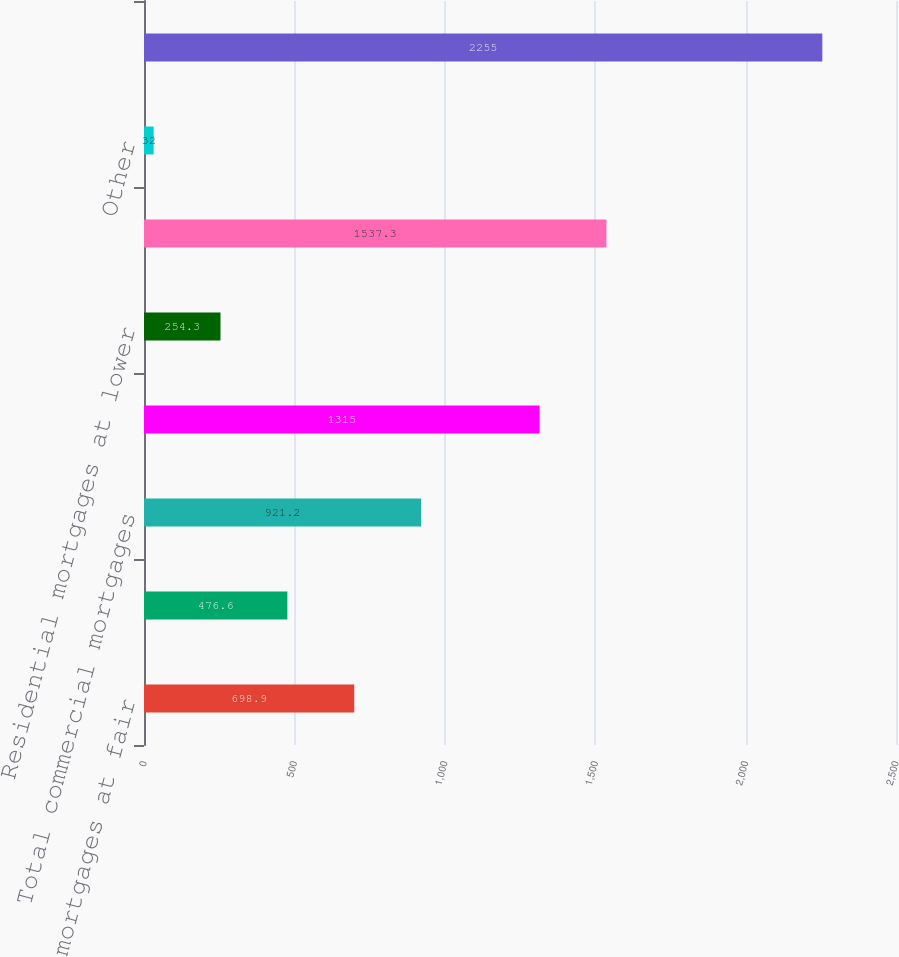<chart> <loc_0><loc_0><loc_500><loc_500><bar_chart><fcel>Commercial mortgages at fair<fcel>Commercial mortgages at lower<fcel>Total commercial mortgages<fcel>Residential mortgages at fair<fcel>Residential mortgages at lower<fcel>Total residential mortgages<fcel>Other<fcel>Total<nl><fcel>698.9<fcel>476.6<fcel>921.2<fcel>1315<fcel>254.3<fcel>1537.3<fcel>32<fcel>2255<nl></chart> 